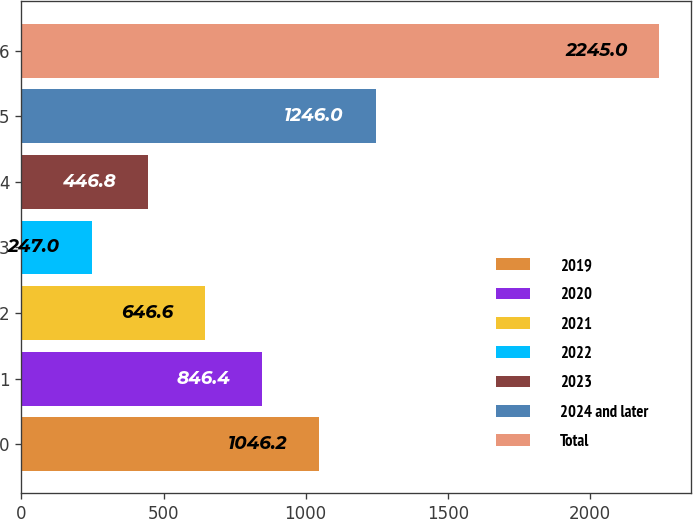Convert chart to OTSL. <chart><loc_0><loc_0><loc_500><loc_500><bar_chart><fcel>2019<fcel>2020<fcel>2021<fcel>2022<fcel>2023<fcel>2024 and later<fcel>Total<nl><fcel>1046.2<fcel>846.4<fcel>646.6<fcel>247<fcel>446.8<fcel>1246<fcel>2245<nl></chart> 